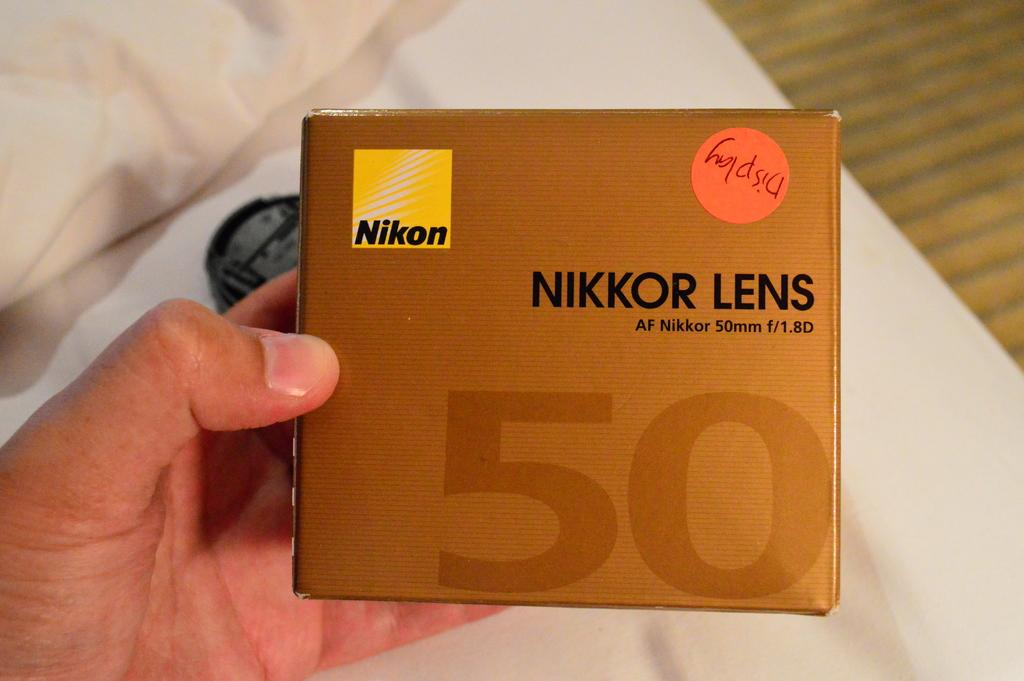<image>
Create a compact narrative representing the image presented. A person is holding a camera lens for a Nikkor 50MM. 